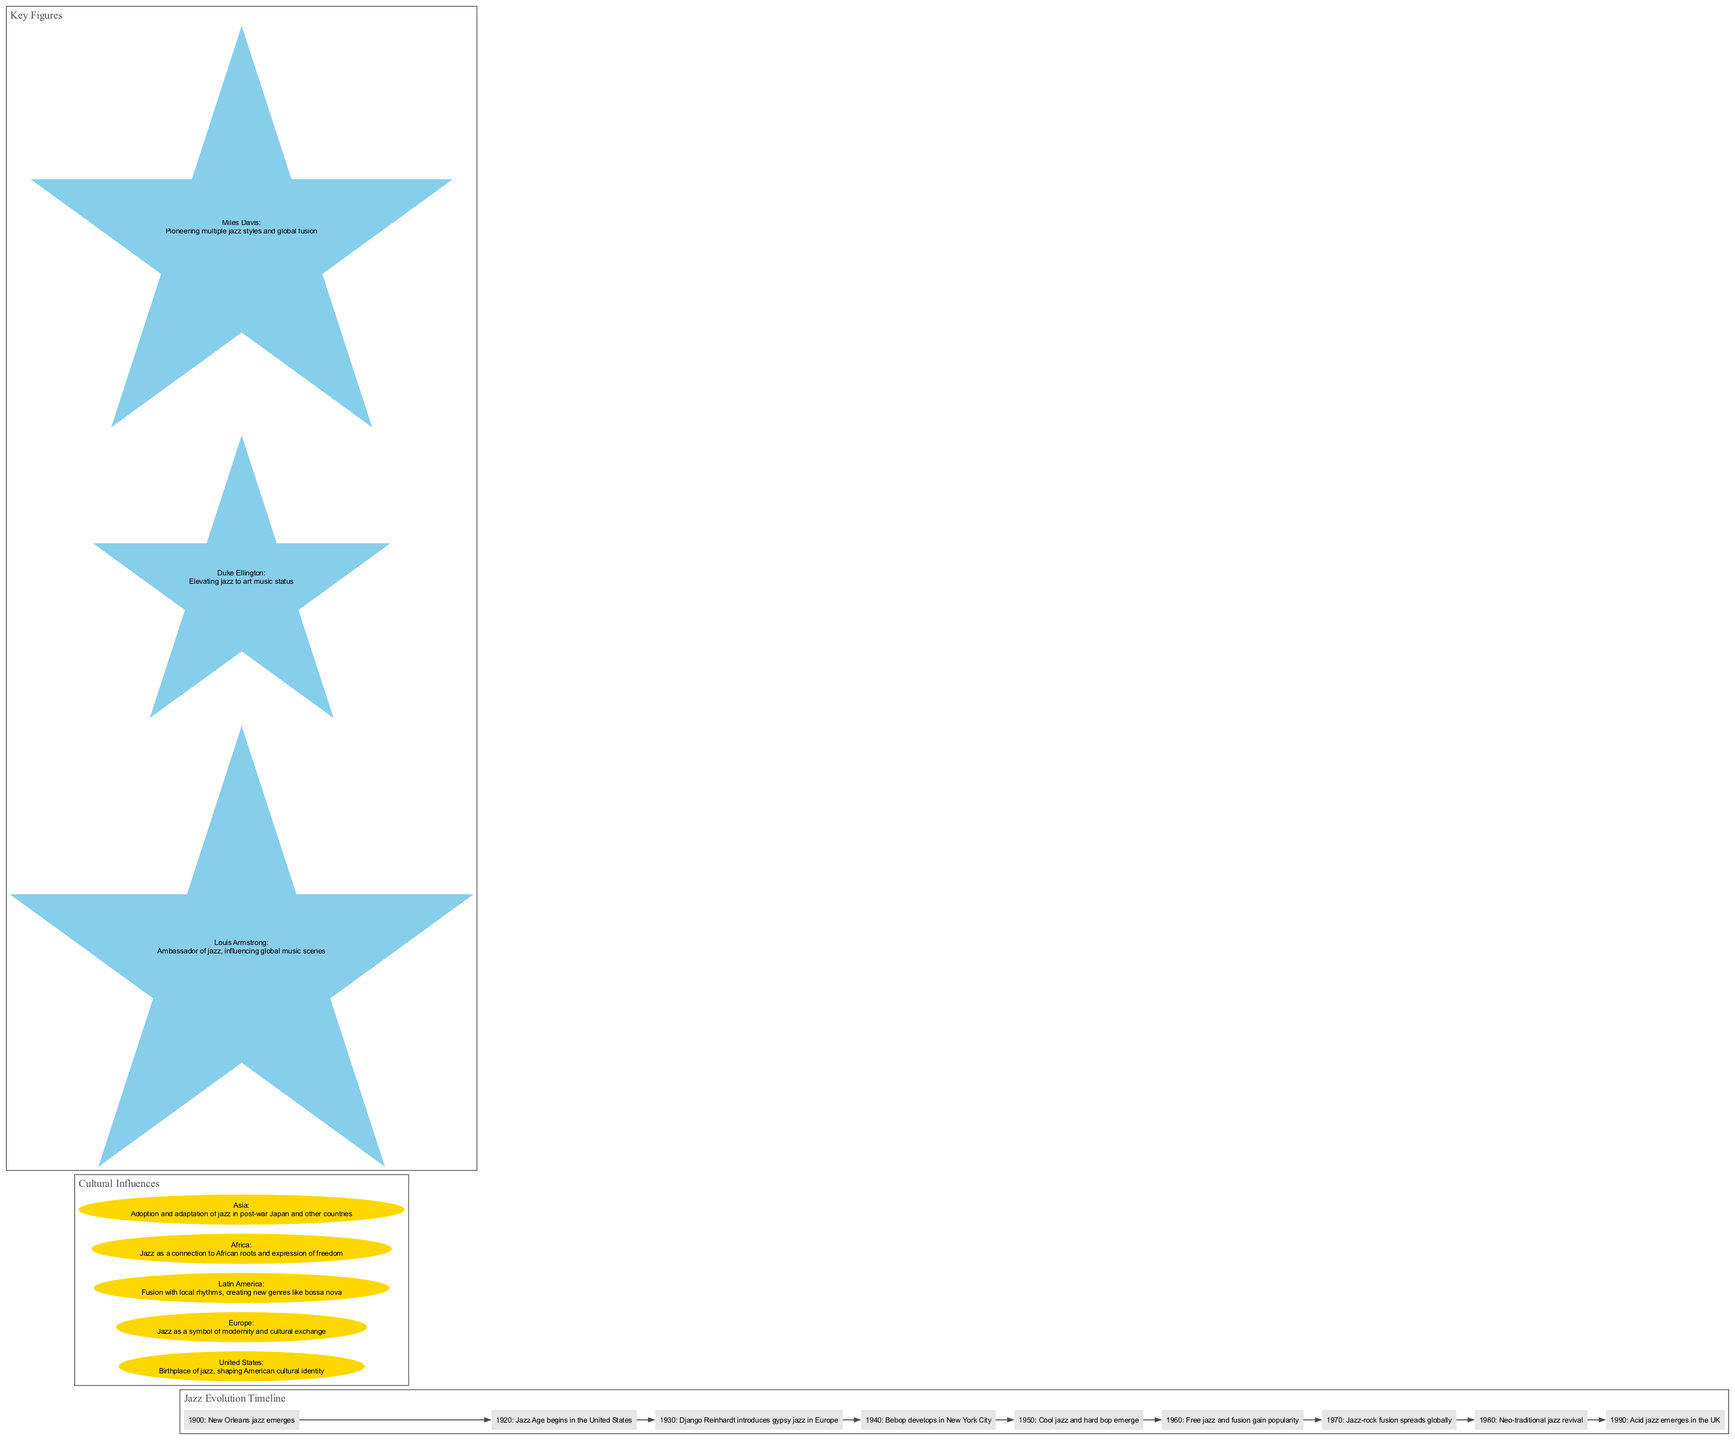What year did New Orleans jazz emerge? According to the timeline, the emergence of New Orleans jazz is documented in the year 1900.
Answer: 1900 What cultural impact does jazz have in the United States? The diagram states that jazz is the birthplace of jazz, shaping American cultural identity according to the cultural influences section.
Answer: Birthplace of jazz, shaping American cultural identity Who is known as the ambassador of jazz? The key figures section identifies Louis Armstrong as the ambassador of jazz, specifically highlighting his influence on global music scenes.
Answer: Louis Armstrong How many events are listed in the timeline? There are 10 entries in the timeline, each representing a different significant event in the evolution of jazz music.
Answer: 10 Which jazz style developed in New York City in the 1940s? The timeline indicates that Bebop develops in New York City specifically in the year 1940.
Answer: Bebop What region is noted for fusion with local rhythms creating new genres like bossa nova? The cultural influences section specifies that Latin America is recognized for its fusion with local rhythms, leading to new genres such as bossa nova.
Answer: Latin America Which two types of jazz emerged in the 1950s? The timeline highlights Cool jazz and hard bop as the two types of jazz that emerged in the year 1950.
Answer: Cool jazz and hard bop Which key figure is known for pioneering multiple jazz styles? According to the key figures section, Miles Davis is noted for pioneering multiple jazz styles and global fusion.
Answer: Miles Davis What event marks the beginning of the Jazz Age in the United States? The timeline denotes that the Jazz Age begins in the year 1920, marking a significant era in American music and culture.
Answer: Jazz Age begins in the United States (1920) 